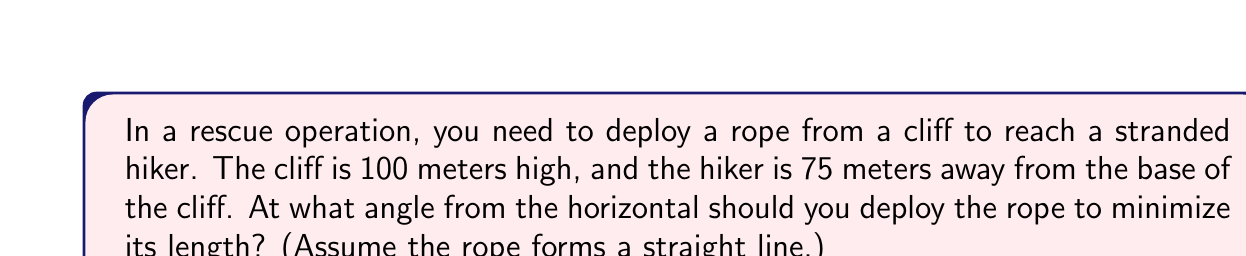Can you answer this question? Let's approach this step-by-step:

1) Let $\theta$ be the angle from the horizontal at which the rope is deployed.

2) We can represent this scenario as a right triangle, where:
   - The height of the cliff (100 m) is the opposite side
   - The distance to the hiker (75 m) is the adjacent side
   - The rope is the hypotenuse

3) The length of the rope (L) can be expressed using the Pythagorean theorem:

   $$L = \sqrt{100^2 + 75^2} = \sqrt{10000 + 5625} = \sqrt{15625} = 125$$

4) Now, we need to find the angle $\theta$ that minimizes this length. We can use the tangent function:

   $$\tan(\theta) = \frac{\text{opposite}}{\text{adjacent}} = \frac{100}{75}$$

5) To find $\theta$, we take the inverse tangent (arctangent):

   $$\theta = \arctan(\frac{100}{75}) \approx 53.13^\circ$$

6) This angle will provide the shortest possible rope length, which we calculated in step 3 to be 125 meters.

7) We can verify this is the optimal angle using calculus, but that's beyond the scope of this problem.

[asy]
import geometry;

size(200);
draw((0,0)--(75,0)--(75,100)--(0,0),black);
draw((0,0)--(75,100),red);
label("100m",(-5,50),W);
label("75m",(37.5,0),S);
label("125m",(37.5,50),NE);
label("θ",(10,10),NE);
[/asy]
Answer: $53.13^\circ$ 